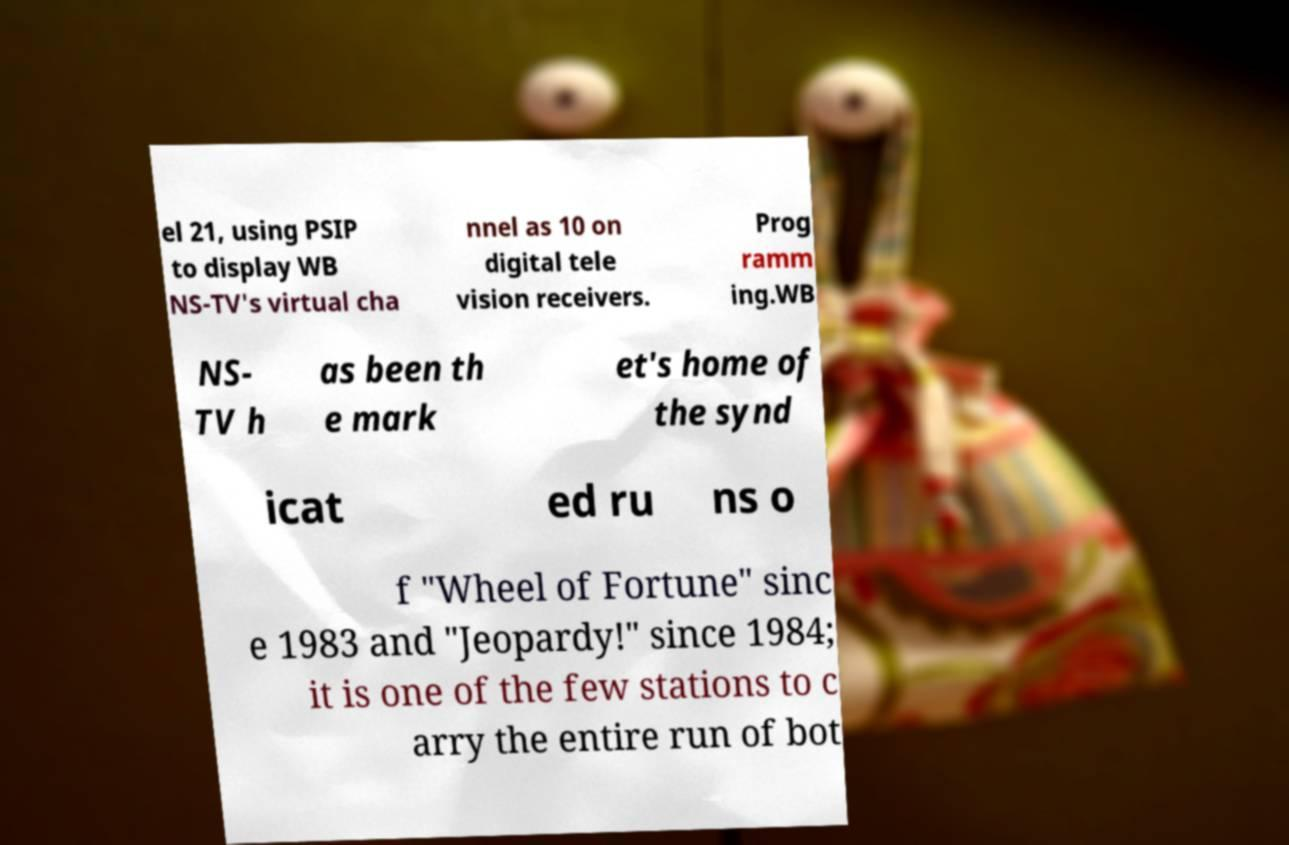Please identify and transcribe the text found in this image. el 21, using PSIP to display WB NS-TV's virtual cha nnel as 10 on digital tele vision receivers. Prog ramm ing.WB NS- TV h as been th e mark et's home of the synd icat ed ru ns o f "Wheel of Fortune" sinc e 1983 and "Jeopardy!" since 1984; it is one of the few stations to c arry the entire run of bot 